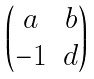Convert formula to latex. <formula><loc_0><loc_0><loc_500><loc_500>\begin{pmatrix} a & b \\ - 1 & d \end{pmatrix}</formula> 